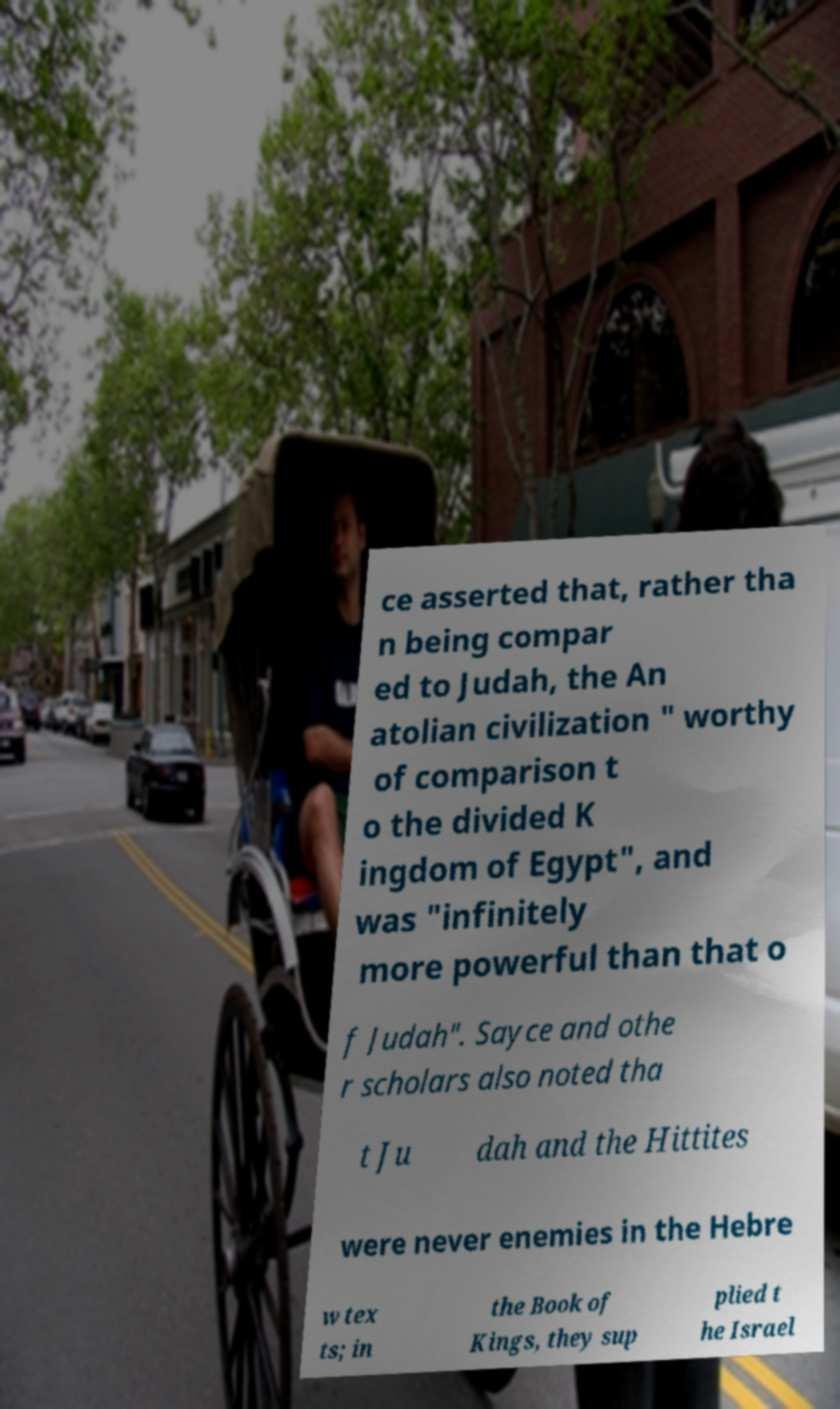Could you assist in decoding the text presented in this image and type it out clearly? ce asserted that, rather tha n being compar ed to Judah, the An atolian civilization " worthy of comparison t o the divided K ingdom of Egypt", and was "infinitely more powerful than that o f Judah". Sayce and othe r scholars also noted tha t Ju dah and the Hittites were never enemies in the Hebre w tex ts; in the Book of Kings, they sup plied t he Israel 